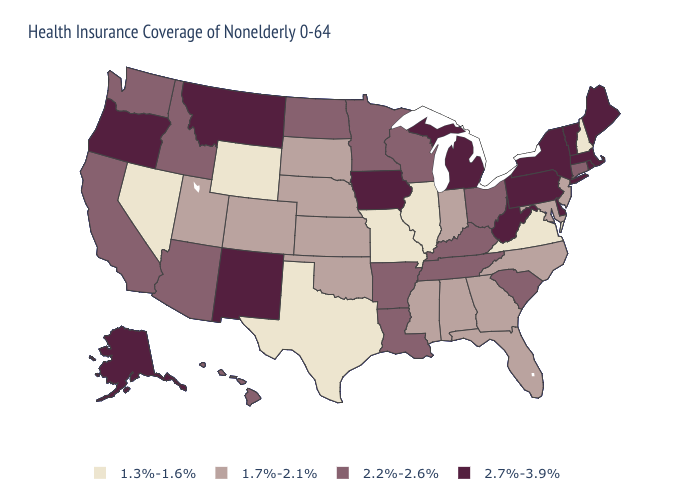What is the highest value in the MidWest ?
Concise answer only. 2.7%-3.9%. What is the value of Colorado?
Write a very short answer. 1.7%-2.1%. What is the lowest value in the USA?
Give a very brief answer. 1.3%-1.6%. Which states hav the highest value in the Northeast?
Give a very brief answer. Maine, Massachusetts, New York, Pennsylvania, Rhode Island, Vermont. Which states have the lowest value in the USA?
Concise answer only. Illinois, Missouri, Nevada, New Hampshire, Texas, Virginia, Wyoming. Among the states that border Kentucky , does West Virginia have the lowest value?
Keep it brief. No. What is the lowest value in the South?
Answer briefly. 1.3%-1.6%. Name the states that have a value in the range 2.2%-2.6%?
Answer briefly. Arizona, Arkansas, California, Connecticut, Hawaii, Idaho, Kentucky, Louisiana, Minnesota, North Dakota, Ohio, South Carolina, Tennessee, Washington, Wisconsin. How many symbols are there in the legend?
Give a very brief answer. 4. How many symbols are there in the legend?
Quick response, please. 4. Does Virginia have the lowest value in the South?
Give a very brief answer. Yes. Does Minnesota have a higher value than Kansas?
Keep it brief. Yes. Is the legend a continuous bar?
Quick response, please. No. What is the value of Michigan?
Give a very brief answer. 2.7%-3.9%. Does the first symbol in the legend represent the smallest category?
Quick response, please. Yes. 